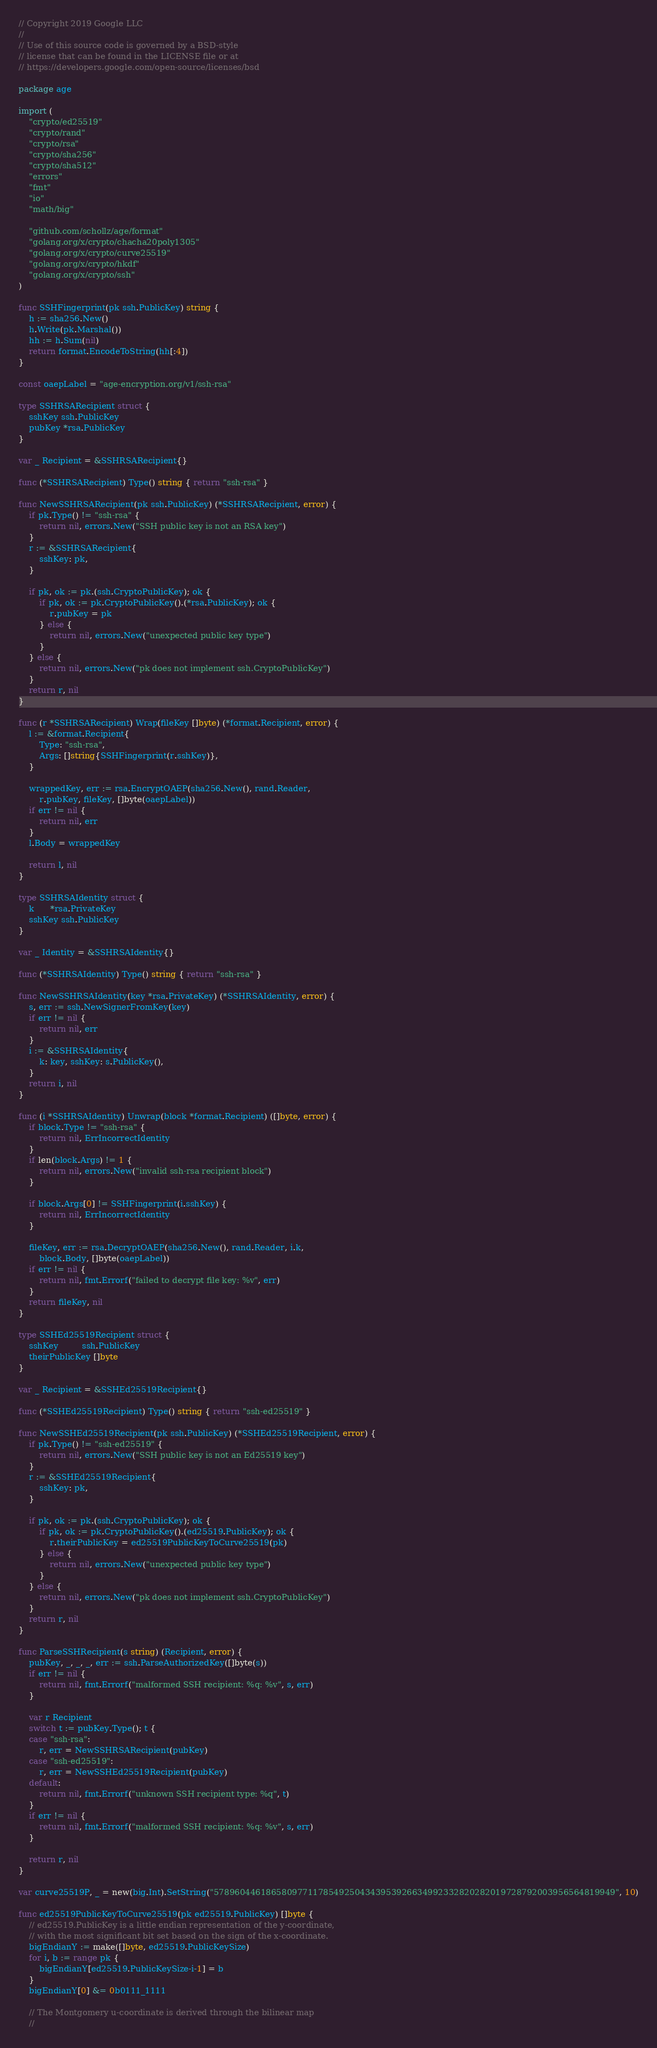Convert code to text. <code><loc_0><loc_0><loc_500><loc_500><_Go_>// Copyright 2019 Google LLC
//
// Use of this source code is governed by a BSD-style
// license that can be found in the LICENSE file or at
// https://developers.google.com/open-source/licenses/bsd

package age

import (
	"crypto/ed25519"
	"crypto/rand"
	"crypto/rsa"
	"crypto/sha256"
	"crypto/sha512"
	"errors"
	"fmt"
	"io"
	"math/big"

	"github.com/schollz/age/format"
	"golang.org/x/crypto/chacha20poly1305"
	"golang.org/x/crypto/curve25519"
	"golang.org/x/crypto/hkdf"
	"golang.org/x/crypto/ssh"
)

func SSHFingerprint(pk ssh.PublicKey) string {
	h := sha256.New()
	h.Write(pk.Marshal())
	hh := h.Sum(nil)
	return format.EncodeToString(hh[:4])
}

const oaepLabel = "age-encryption.org/v1/ssh-rsa"

type SSHRSARecipient struct {
	sshKey ssh.PublicKey
	pubKey *rsa.PublicKey
}

var _ Recipient = &SSHRSARecipient{}

func (*SSHRSARecipient) Type() string { return "ssh-rsa" }

func NewSSHRSARecipient(pk ssh.PublicKey) (*SSHRSARecipient, error) {
	if pk.Type() != "ssh-rsa" {
		return nil, errors.New("SSH public key is not an RSA key")
	}
	r := &SSHRSARecipient{
		sshKey: pk,
	}

	if pk, ok := pk.(ssh.CryptoPublicKey); ok {
		if pk, ok := pk.CryptoPublicKey().(*rsa.PublicKey); ok {
			r.pubKey = pk
		} else {
			return nil, errors.New("unexpected public key type")
		}
	} else {
		return nil, errors.New("pk does not implement ssh.CryptoPublicKey")
	}
	return r, nil
}

func (r *SSHRSARecipient) Wrap(fileKey []byte) (*format.Recipient, error) {
	l := &format.Recipient{
		Type: "ssh-rsa",
		Args: []string{SSHFingerprint(r.sshKey)},
	}

	wrappedKey, err := rsa.EncryptOAEP(sha256.New(), rand.Reader,
		r.pubKey, fileKey, []byte(oaepLabel))
	if err != nil {
		return nil, err
	}
	l.Body = wrappedKey

	return l, nil
}

type SSHRSAIdentity struct {
	k      *rsa.PrivateKey
	sshKey ssh.PublicKey
}

var _ Identity = &SSHRSAIdentity{}

func (*SSHRSAIdentity) Type() string { return "ssh-rsa" }

func NewSSHRSAIdentity(key *rsa.PrivateKey) (*SSHRSAIdentity, error) {
	s, err := ssh.NewSignerFromKey(key)
	if err != nil {
		return nil, err
	}
	i := &SSHRSAIdentity{
		k: key, sshKey: s.PublicKey(),
	}
	return i, nil
}

func (i *SSHRSAIdentity) Unwrap(block *format.Recipient) ([]byte, error) {
	if block.Type != "ssh-rsa" {
		return nil, ErrIncorrectIdentity
	}
	if len(block.Args) != 1 {
		return nil, errors.New("invalid ssh-rsa recipient block")
	}

	if block.Args[0] != SSHFingerprint(i.sshKey) {
		return nil, ErrIncorrectIdentity
	}

	fileKey, err := rsa.DecryptOAEP(sha256.New(), rand.Reader, i.k,
		block.Body, []byte(oaepLabel))
	if err != nil {
		return nil, fmt.Errorf("failed to decrypt file key: %v", err)
	}
	return fileKey, nil
}

type SSHEd25519Recipient struct {
	sshKey         ssh.PublicKey
	theirPublicKey []byte
}

var _ Recipient = &SSHEd25519Recipient{}

func (*SSHEd25519Recipient) Type() string { return "ssh-ed25519" }

func NewSSHEd25519Recipient(pk ssh.PublicKey) (*SSHEd25519Recipient, error) {
	if pk.Type() != "ssh-ed25519" {
		return nil, errors.New("SSH public key is not an Ed25519 key")
	}
	r := &SSHEd25519Recipient{
		sshKey: pk,
	}

	if pk, ok := pk.(ssh.CryptoPublicKey); ok {
		if pk, ok := pk.CryptoPublicKey().(ed25519.PublicKey); ok {
			r.theirPublicKey = ed25519PublicKeyToCurve25519(pk)
		} else {
			return nil, errors.New("unexpected public key type")
		}
	} else {
		return nil, errors.New("pk does not implement ssh.CryptoPublicKey")
	}
	return r, nil
}

func ParseSSHRecipient(s string) (Recipient, error) {
	pubKey, _, _, _, err := ssh.ParseAuthorizedKey([]byte(s))
	if err != nil {
		return nil, fmt.Errorf("malformed SSH recipient: %q: %v", s, err)
	}

	var r Recipient
	switch t := pubKey.Type(); t {
	case "ssh-rsa":
		r, err = NewSSHRSARecipient(pubKey)
	case "ssh-ed25519":
		r, err = NewSSHEd25519Recipient(pubKey)
	default:
		return nil, fmt.Errorf("unknown SSH recipient type: %q", t)
	}
	if err != nil {
		return nil, fmt.Errorf("malformed SSH recipient: %q: %v", s, err)
	}

	return r, nil
}

var curve25519P, _ = new(big.Int).SetString("57896044618658097711785492504343953926634992332820282019728792003956564819949", 10)

func ed25519PublicKeyToCurve25519(pk ed25519.PublicKey) []byte {
	// ed25519.PublicKey is a little endian representation of the y-coordinate,
	// with the most significant bit set based on the sign of the x-coordinate.
	bigEndianY := make([]byte, ed25519.PublicKeySize)
	for i, b := range pk {
		bigEndianY[ed25519.PublicKeySize-i-1] = b
	}
	bigEndianY[0] &= 0b0111_1111

	// The Montgomery u-coordinate is derived through the bilinear map
	//</code> 